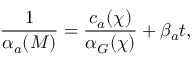<formula> <loc_0><loc_0><loc_500><loc_500>\frac { 1 } { \alpha _ { a } ( M ) } = \frac { c _ { a } ( \chi ) } { \alpha _ { G } ( \chi ) } + \beta _ { a } t ,</formula> 